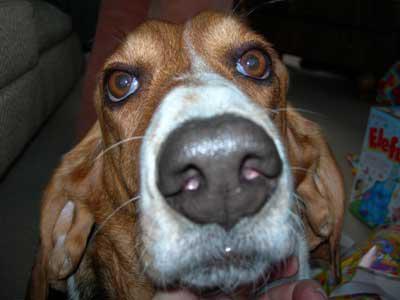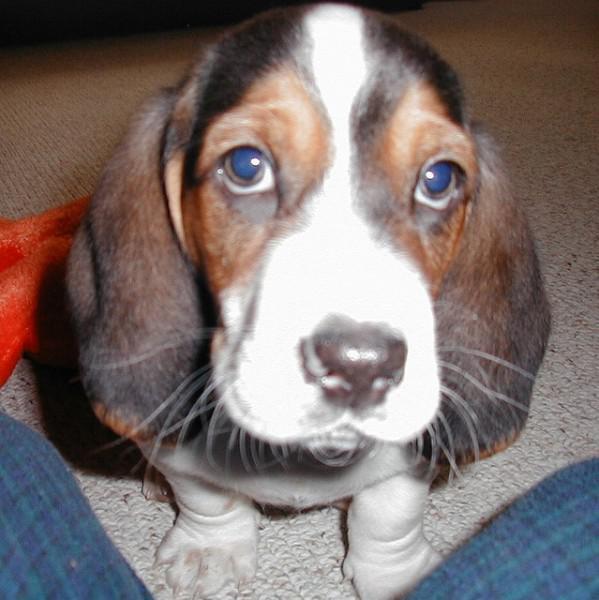The first image is the image on the left, the second image is the image on the right. Evaluate the accuracy of this statement regarding the images: "a dog is wearing a costume". Is it true? Answer yes or no. No. 